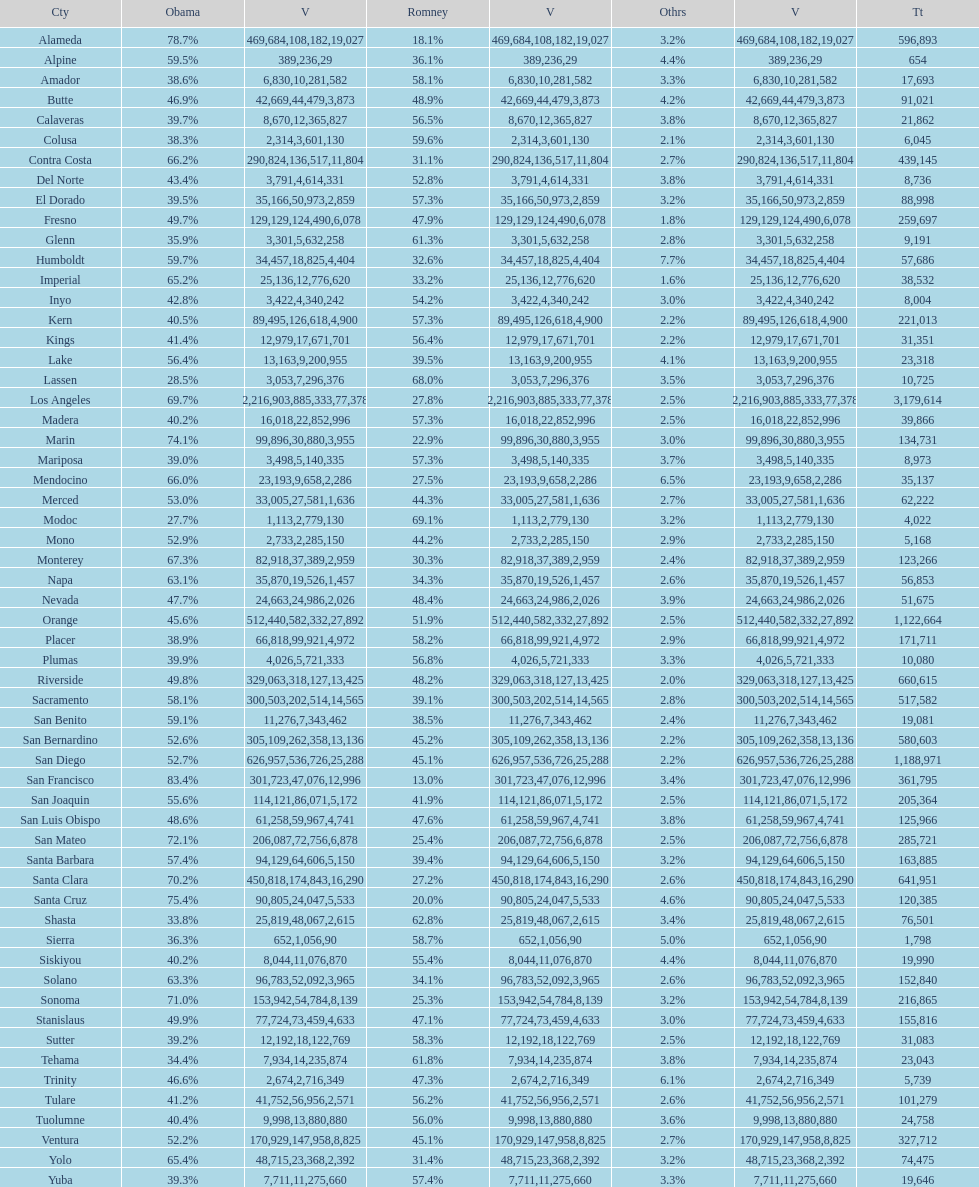How many counties had at least 75% of the votes for obama? 3. 